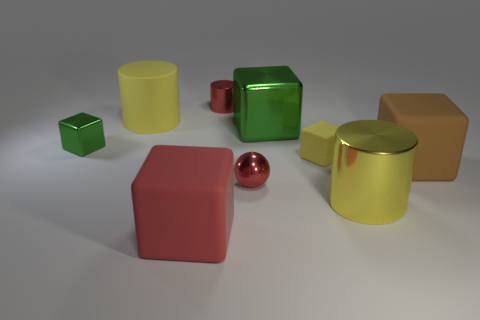How big is the red metal thing in front of the yellow matte cube on the right side of the large block on the left side of the tiny shiny cylinder?
Provide a succinct answer. Small. What is the material of the yellow thing behind the green block that is right of the big yellow matte object?
Provide a succinct answer. Rubber. Is there a small red metal thing that has the same shape as the tiny yellow matte thing?
Make the answer very short. No. The big yellow rubber object has what shape?
Offer a terse response. Cylinder. The thing that is on the right side of the yellow thing in front of the brown rubber thing that is right of the small sphere is made of what material?
Provide a short and direct response. Rubber. Is the number of big yellow cylinders left of the large green thing greater than the number of brown metal things?
Provide a succinct answer. Yes. What is the material of the yellow cube that is the same size as the red cylinder?
Provide a short and direct response. Rubber. Are there any red balls of the same size as the yellow block?
Offer a terse response. Yes. How big is the yellow rubber thing that is behind the tiny green cube?
Keep it short and to the point. Large. The red matte object is what size?
Your answer should be very brief. Large. 